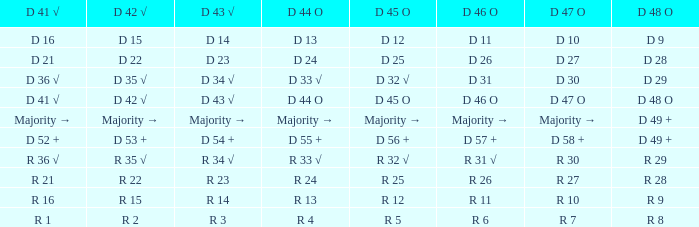Determine the d 48 o connected to d 41 √ when considering d 41 √. D 48 O. 